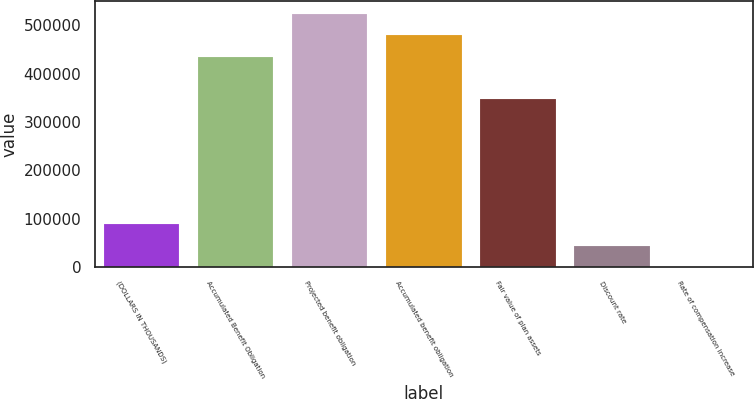Convert chart to OTSL. <chart><loc_0><loc_0><loc_500><loc_500><bar_chart><fcel>(DOLLARS IN THOUSANDS)<fcel>Accumulated Benefit Obligation<fcel>Projected benefit obligation<fcel>Accumulated benefit obligation<fcel>Fair value of plan assets<fcel>Discount rate<fcel>Rate of compensation increase<nl><fcel>88131.8<fcel>435123<fcel>523252<fcel>479187<fcel>347084<fcel>44067.5<fcel>3.25<nl></chart> 